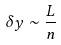Convert formula to latex. <formula><loc_0><loc_0><loc_500><loc_500>\delta y \sim \frac { L } { n }</formula> 